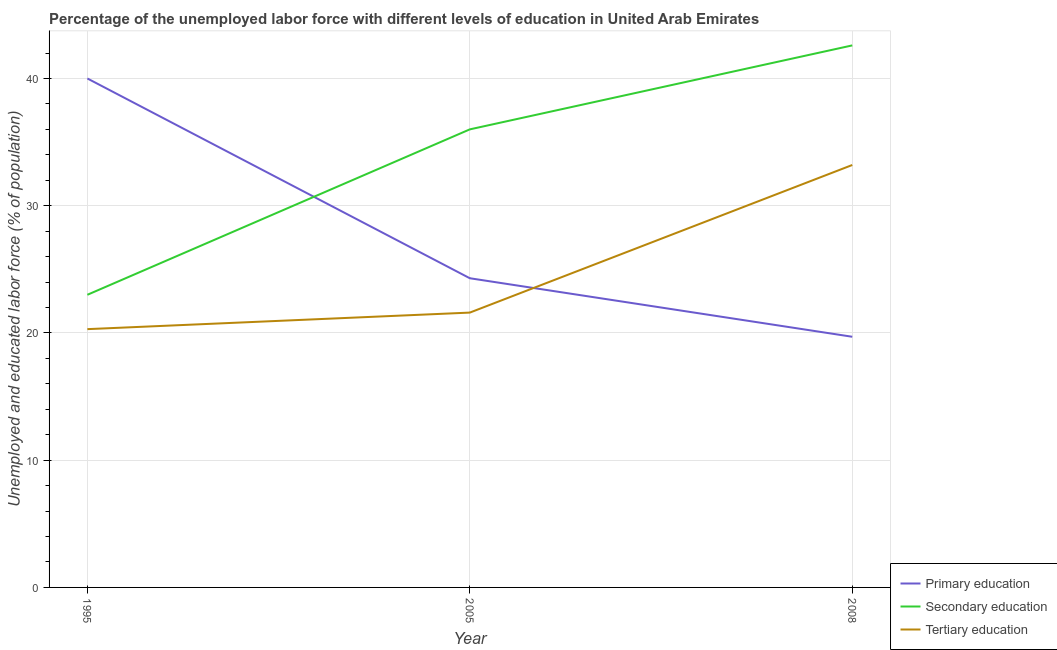Does the line corresponding to percentage of labor force who received secondary education intersect with the line corresponding to percentage of labor force who received primary education?
Your answer should be compact. Yes. Across all years, what is the maximum percentage of labor force who received secondary education?
Keep it short and to the point. 42.6. Across all years, what is the minimum percentage of labor force who received primary education?
Provide a succinct answer. 19.7. In which year was the percentage of labor force who received tertiary education minimum?
Offer a very short reply. 1995. What is the difference between the percentage of labor force who received tertiary education in 1995 and that in 2008?
Provide a short and direct response. -12.9. What is the difference between the percentage of labor force who received tertiary education in 2008 and the percentage of labor force who received secondary education in 1995?
Provide a short and direct response. 10.2. What is the average percentage of labor force who received secondary education per year?
Give a very brief answer. 33.87. In the year 2005, what is the difference between the percentage of labor force who received primary education and percentage of labor force who received tertiary education?
Give a very brief answer. 2.7. In how many years, is the percentage of labor force who received tertiary education greater than 22 %?
Your answer should be compact. 1. What is the ratio of the percentage of labor force who received secondary education in 2005 to that in 2008?
Keep it short and to the point. 0.85. Is the percentage of labor force who received primary education in 1995 less than that in 2008?
Keep it short and to the point. No. What is the difference between the highest and the second highest percentage of labor force who received secondary education?
Give a very brief answer. 6.6. What is the difference between the highest and the lowest percentage of labor force who received primary education?
Your answer should be compact. 20.3. Is the sum of the percentage of labor force who received secondary education in 1995 and 2005 greater than the maximum percentage of labor force who received tertiary education across all years?
Provide a short and direct response. Yes. Does the percentage of labor force who received primary education monotonically increase over the years?
Make the answer very short. No. How many lines are there?
Provide a short and direct response. 3. What is the difference between two consecutive major ticks on the Y-axis?
Ensure brevity in your answer.  10. Does the graph contain any zero values?
Provide a succinct answer. No. Does the graph contain grids?
Provide a short and direct response. Yes. Where does the legend appear in the graph?
Provide a succinct answer. Bottom right. What is the title of the graph?
Make the answer very short. Percentage of the unemployed labor force with different levels of education in United Arab Emirates. Does "Ages 20-50" appear as one of the legend labels in the graph?
Keep it short and to the point. No. What is the label or title of the Y-axis?
Provide a succinct answer. Unemployed and educated labor force (% of population). What is the Unemployed and educated labor force (% of population) of Secondary education in 1995?
Keep it short and to the point. 23. What is the Unemployed and educated labor force (% of population) of Tertiary education in 1995?
Your response must be concise. 20.3. What is the Unemployed and educated labor force (% of population) in Primary education in 2005?
Your response must be concise. 24.3. What is the Unemployed and educated labor force (% of population) of Tertiary education in 2005?
Provide a short and direct response. 21.6. What is the Unemployed and educated labor force (% of population) of Primary education in 2008?
Your answer should be compact. 19.7. What is the Unemployed and educated labor force (% of population) in Secondary education in 2008?
Give a very brief answer. 42.6. What is the Unemployed and educated labor force (% of population) in Tertiary education in 2008?
Your answer should be compact. 33.2. Across all years, what is the maximum Unemployed and educated labor force (% of population) in Secondary education?
Make the answer very short. 42.6. Across all years, what is the maximum Unemployed and educated labor force (% of population) in Tertiary education?
Your response must be concise. 33.2. Across all years, what is the minimum Unemployed and educated labor force (% of population) in Primary education?
Provide a succinct answer. 19.7. Across all years, what is the minimum Unemployed and educated labor force (% of population) of Tertiary education?
Ensure brevity in your answer.  20.3. What is the total Unemployed and educated labor force (% of population) in Secondary education in the graph?
Give a very brief answer. 101.6. What is the total Unemployed and educated labor force (% of population) in Tertiary education in the graph?
Provide a short and direct response. 75.1. What is the difference between the Unemployed and educated labor force (% of population) of Secondary education in 1995 and that in 2005?
Keep it short and to the point. -13. What is the difference between the Unemployed and educated labor force (% of population) in Tertiary education in 1995 and that in 2005?
Ensure brevity in your answer.  -1.3. What is the difference between the Unemployed and educated labor force (% of population) in Primary education in 1995 and that in 2008?
Offer a very short reply. 20.3. What is the difference between the Unemployed and educated labor force (% of population) in Secondary education in 1995 and that in 2008?
Your answer should be compact. -19.6. What is the difference between the Unemployed and educated labor force (% of population) in Primary education in 2005 and that in 2008?
Offer a very short reply. 4.6. What is the difference between the Unemployed and educated labor force (% of population) in Tertiary education in 2005 and that in 2008?
Give a very brief answer. -11.6. What is the difference between the Unemployed and educated labor force (% of population) in Primary education in 1995 and the Unemployed and educated labor force (% of population) in Tertiary education in 2005?
Your response must be concise. 18.4. What is the difference between the Unemployed and educated labor force (% of population) in Primary education in 1995 and the Unemployed and educated labor force (% of population) in Secondary education in 2008?
Give a very brief answer. -2.6. What is the difference between the Unemployed and educated labor force (% of population) of Primary education in 1995 and the Unemployed and educated labor force (% of population) of Tertiary education in 2008?
Keep it short and to the point. 6.8. What is the difference between the Unemployed and educated labor force (% of population) of Secondary education in 1995 and the Unemployed and educated labor force (% of population) of Tertiary education in 2008?
Your answer should be very brief. -10.2. What is the difference between the Unemployed and educated labor force (% of population) of Primary education in 2005 and the Unemployed and educated labor force (% of population) of Secondary education in 2008?
Make the answer very short. -18.3. What is the difference between the Unemployed and educated labor force (% of population) of Primary education in 2005 and the Unemployed and educated labor force (% of population) of Tertiary education in 2008?
Offer a terse response. -8.9. What is the average Unemployed and educated labor force (% of population) in Primary education per year?
Offer a very short reply. 28. What is the average Unemployed and educated labor force (% of population) of Secondary education per year?
Make the answer very short. 33.87. What is the average Unemployed and educated labor force (% of population) of Tertiary education per year?
Keep it short and to the point. 25.03. In the year 1995, what is the difference between the Unemployed and educated labor force (% of population) of Primary education and Unemployed and educated labor force (% of population) of Secondary education?
Your response must be concise. 17. In the year 1995, what is the difference between the Unemployed and educated labor force (% of population) of Primary education and Unemployed and educated labor force (% of population) of Tertiary education?
Your answer should be compact. 19.7. In the year 2005, what is the difference between the Unemployed and educated labor force (% of population) of Primary education and Unemployed and educated labor force (% of population) of Secondary education?
Your answer should be very brief. -11.7. In the year 2005, what is the difference between the Unemployed and educated labor force (% of population) in Secondary education and Unemployed and educated labor force (% of population) in Tertiary education?
Your answer should be very brief. 14.4. In the year 2008, what is the difference between the Unemployed and educated labor force (% of population) in Primary education and Unemployed and educated labor force (% of population) in Secondary education?
Your answer should be compact. -22.9. In the year 2008, what is the difference between the Unemployed and educated labor force (% of population) of Primary education and Unemployed and educated labor force (% of population) of Tertiary education?
Keep it short and to the point. -13.5. What is the ratio of the Unemployed and educated labor force (% of population) of Primary education in 1995 to that in 2005?
Give a very brief answer. 1.65. What is the ratio of the Unemployed and educated labor force (% of population) in Secondary education in 1995 to that in 2005?
Keep it short and to the point. 0.64. What is the ratio of the Unemployed and educated labor force (% of population) of Tertiary education in 1995 to that in 2005?
Keep it short and to the point. 0.94. What is the ratio of the Unemployed and educated labor force (% of population) in Primary education in 1995 to that in 2008?
Offer a very short reply. 2.03. What is the ratio of the Unemployed and educated labor force (% of population) in Secondary education in 1995 to that in 2008?
Make the answer very short. 0.54. What is the ratio of the Unemployed and educated labor force (% of population) in Tertiary education in 1995 to that in 2008?
Keep it short and to the point. 0.61. What is the ratio of the Unemployed and educated labor force (% of population) of Primary education in 2005 to that in 2008?
Your answer should be very brief. 1.23. What is the ratio of the Unemployed and educated labor force (% of population) of Secondary education in 2005 to that in 2008?
Provide a short and direct response. 0.85. What is the ratio of the Unemployed and educated labor force (% of population) in Tertiary education in 2005 to that in 2008?
Make the answer very short. 0.65. What is the difference between the highest and the second highest Unemployed and educated labor force (% of population) of Primary education?
Your response must be concise. 15.7. What is the difference between the highest and the lowest Unemployed and educated labor force (% of population) in Primary education?
Offer a very short reply. 20.3. What is the difference between the highest and the lowest Unemployed and educated labor force (% of population) in Secondary education?
Your response must be concise. 19.6. 